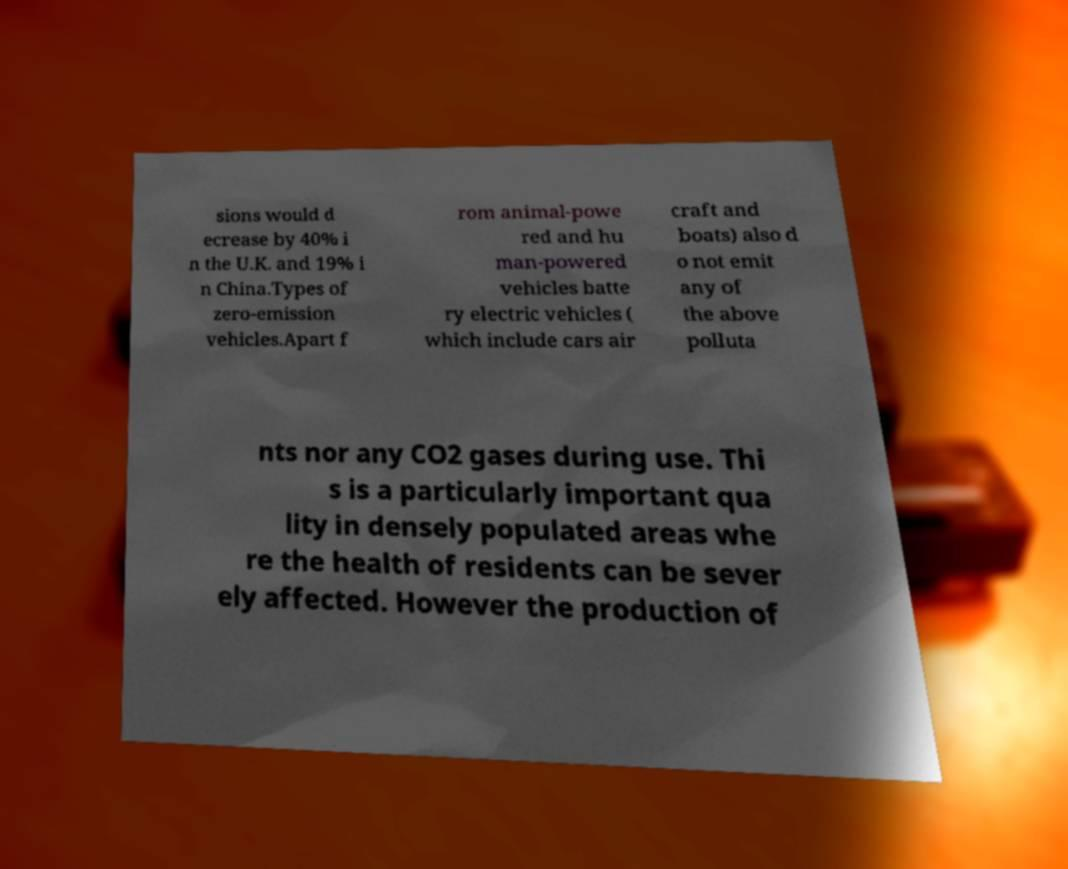Can you accurately transcribe the text from the provided image for me? sions would d ecrease by 40% i n the U.K. and 19% i n China.Types of zero-emission vehicles.Apart f rom animal-powe red and hu man-powered vehicles batte ry electric vehicles ( which include cars air craft and boats) also d o not emit any of the above polluta nts nor any CO2 gases during use. Thi s is a particularly important qua lity in densely populated areas whe re the health of residents can be sever ely affected. However the production of 